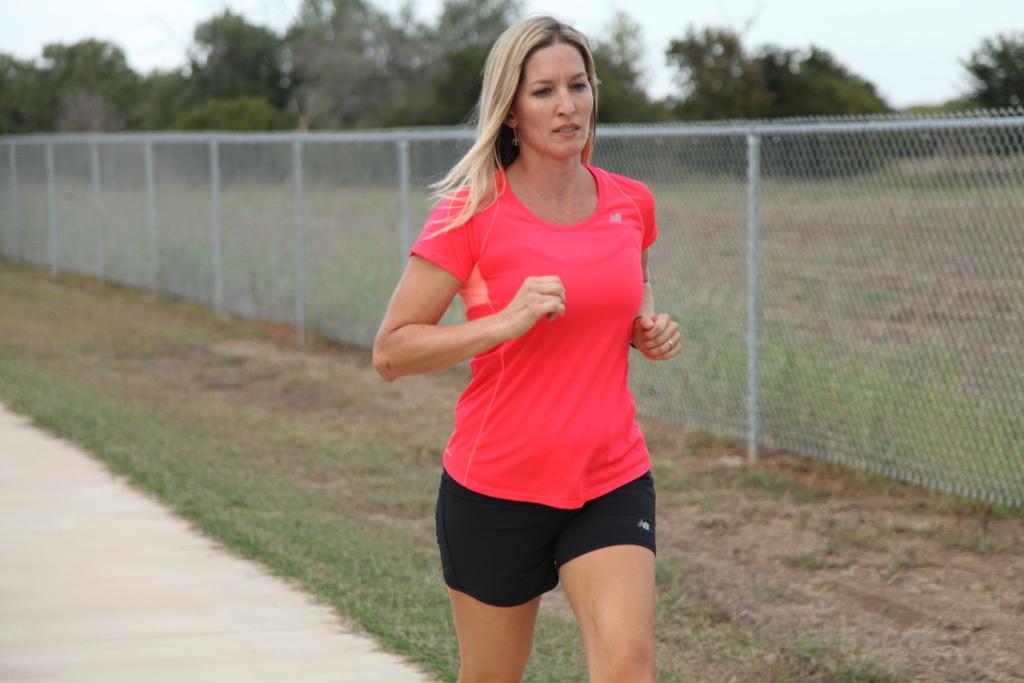Could you give a brief overview of what you see in this image? In the center of the image we can see a lady jogging. In the background there is a fence and we can see trees. There is sky. At the bottom there is grass. 